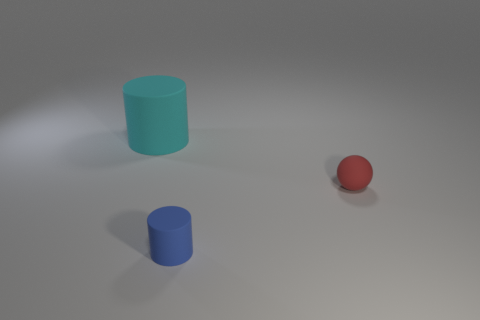Subtract all cyan cylinders. How many cylinders are left? 1 Add 3 large metal cylinders. How many objects exist? 6 Subtract all balls. How many objects are left? 2 Subtract 1 balls. How many balls are left? 0 Add 3 small red rubber objects. How many small red rubber objects exist? 4 Subtract 1 blue cylinders. How many objects are left? 2 Subtract all blue cylinders. Subtract all brown balls. How many cylinders are left? 1 Subtract all green cylinders. How many cyan spheres are left? 0 Subtract all red objects. Subtract all tiny rubber objects. How many objects are left? 0 Add 3 small blue matte cylinders. How many small blue matte cylinders are left? 4 